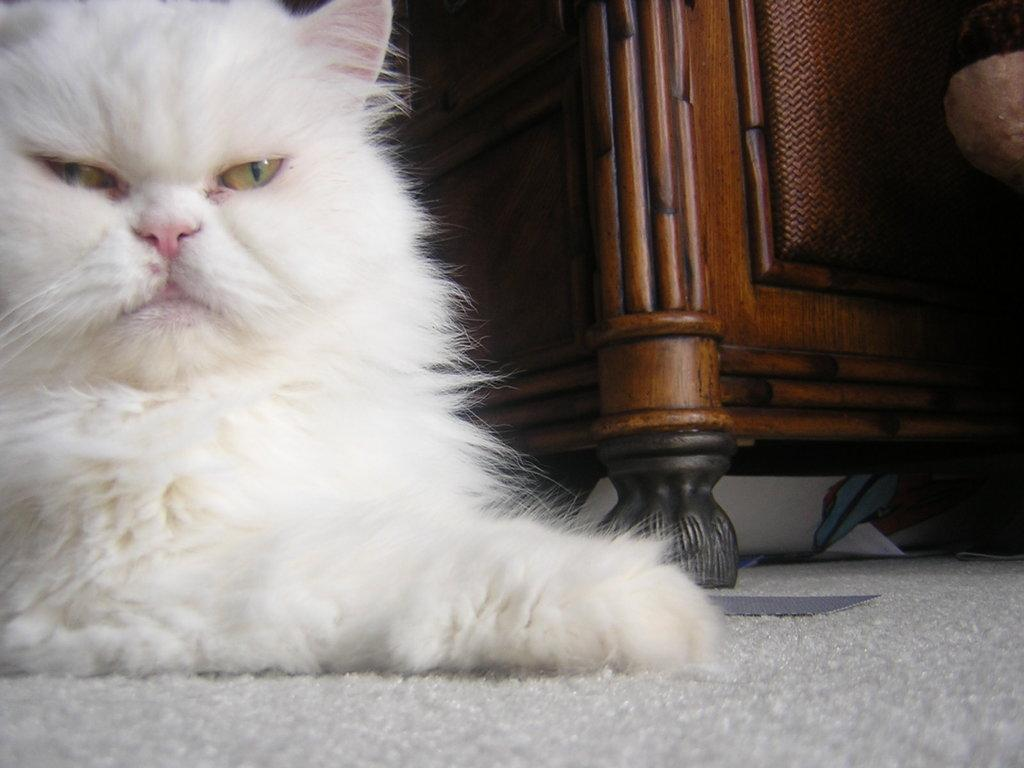What type of animal is in the image? There is a cat in the image. What color is the cat? The cat is white in color. What material is the wooden object made of? The wooden object is made of wood. How does the cat compare to a loaf of bread in the image? There is no loaf of bread present in the image, so it is not possible to make a comparison between the cat and a loaf of bread. 